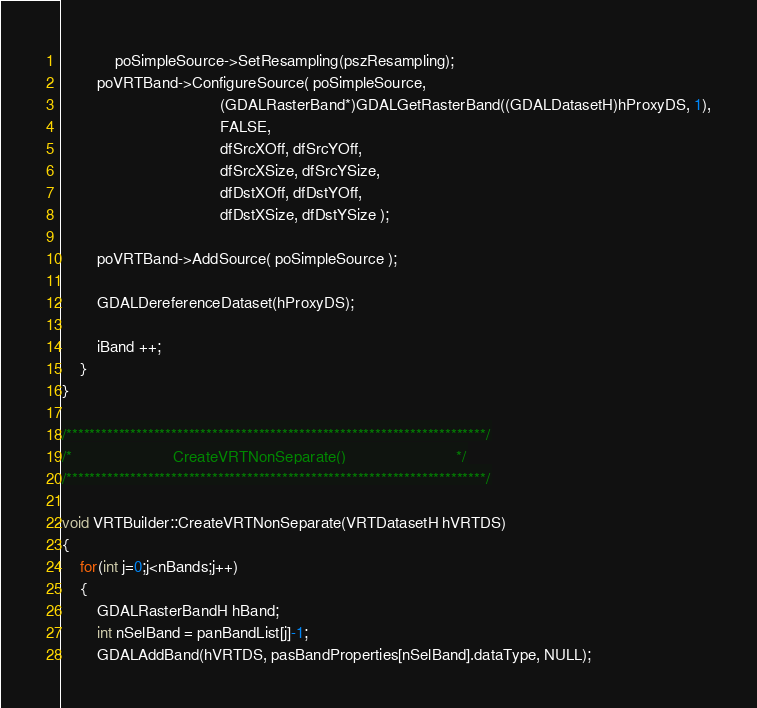<code> <loc_0><loc_0><loc_500><loc_500><_C++_>            poSimpleSource->SetResampling(pszResampling);
        poVRTBand->ConfigureSource( poSimpleSource,
                                    (GDALRasterBand*)GDALGetRasterBand((GDALDatasetH)hProxyDS, 1),
                                    FALSE,
                                    dfSrcXOff, dfSrcYOff,
                                    dfSrcXSize, dfSrcYSize,
                                    dfDstXOff, dfDstYOff,
                                    dfDstXSize, dfDstYSize );

        poVRTBand->AddSource( poSimpleSource );

        GDALDereferenceDataset(hProxyDS);

        iBand ++;
    }
}

/************************************************************************/
/*                       CreateVRTNonSeparate()                         */
/************************************************************************/

void VRTBuilder::CreateVRTNonSeparate(VRTDatasetH hVRTDS)
{
    for(int j=0;j<nBands;j++)
    {
        GDALRasterBandH hBand;
        int nSelBand = panBandList[j]-1;
        GDALAddBand(hVRTDS, pasBandProperties[nSelBand].dataType, NULL);</code> 